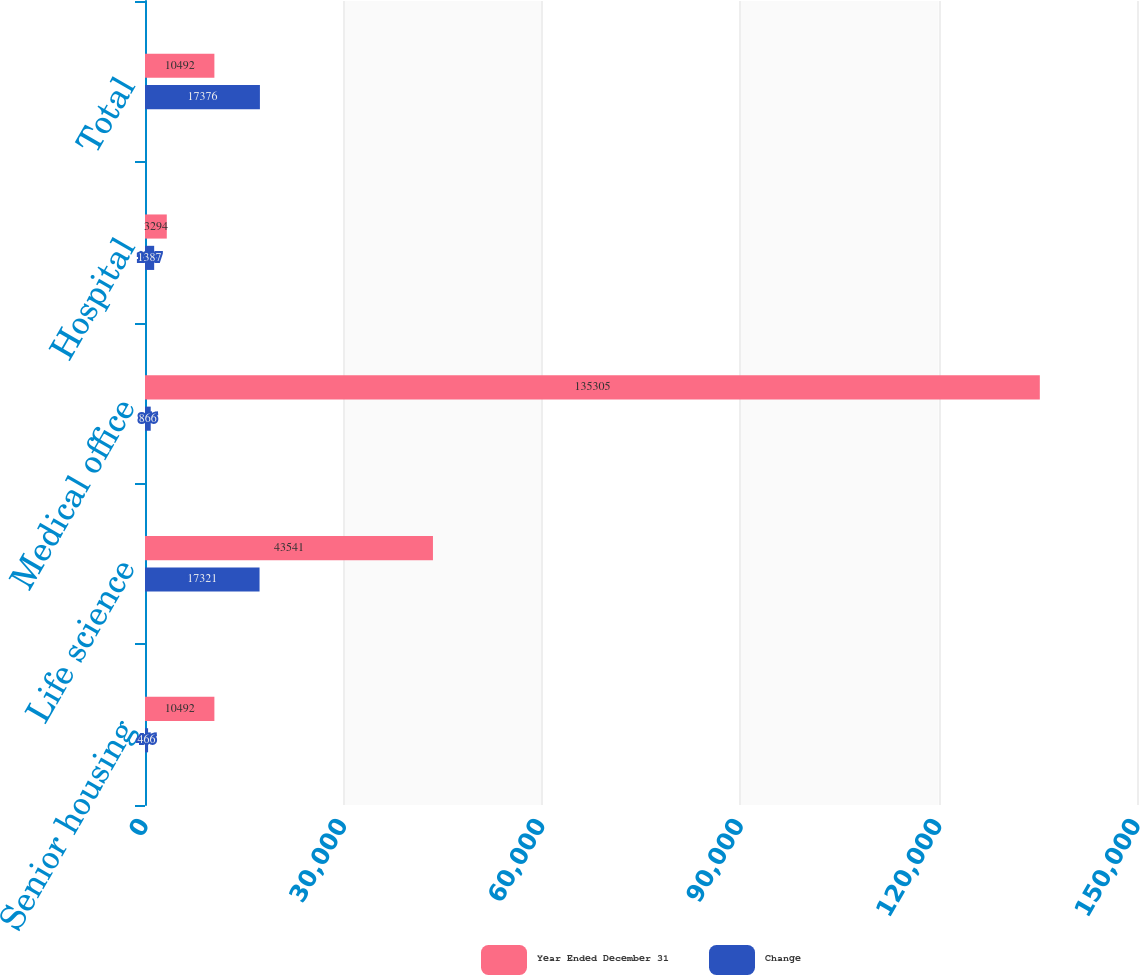Convert chart to OTSL. <chart><loc_0><loc_0><loc_500><loc_500><stacked_bar_chart><ecel><fcel>Senior housing<fcel>Life science<fcel>Medical office<fcel>Hospital<fcel>Total<nl><fcel>Year Ended December 31<fcel>10492<fcel>43541<fcel>135305<fcel>3294<fcel>10492<nl><fcel>Change<fcel>466<fcel>17321<fcel>866<fcel>1387<fcel>17376<nl></chart> 